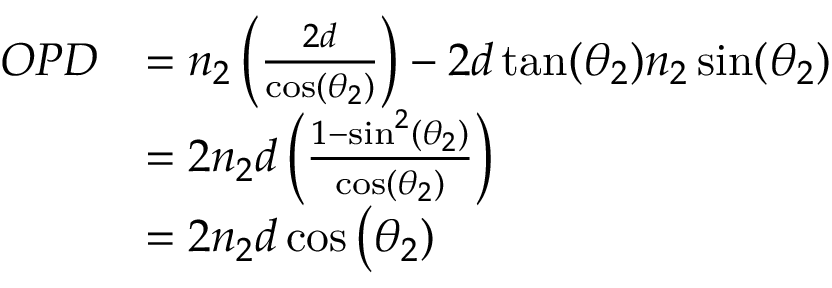<formula> <loc_0><loc_0><loc_500><loc_500>{ \begin{array} { r l } { O P D } & { = n _ { 2 } \left ( { \frac { 2 d } { \cos ( \theta _ { 2 } ) } } \right ) - 2 d \tan ( \theta _ { 2 } ) n _ { 2 } \sin ( \theta _ { 2 } ) } \\ & { = 2 n _ { 2 } d \left ( { \frac { 1 - \sin ^ { 2 } ( \theta _ { 2 } ) } { \cos ( \theta _ { 2 } ) } } \right ) } \\ & { = 2 n _ { 2 } d \cos { \Big ( } \theta _ { 2 } ) } \end{array} }</formula> 